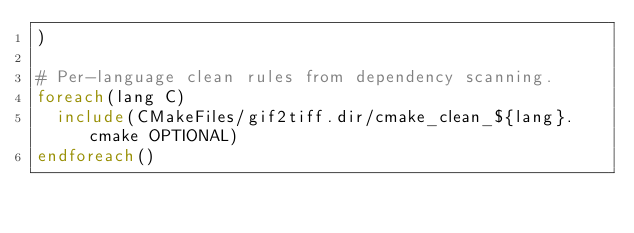Convert code to text. <code><loc_0><loc_0><loc_500><loc_500><_CMake_>)

# Per-language clean rules from dependency scanning.
foreach(lang C)
  include(CMakeFiles/gif2tiff.dir/cmake_clean_${lang}.cmake OPTIONAL)
endforeach()
</code> 